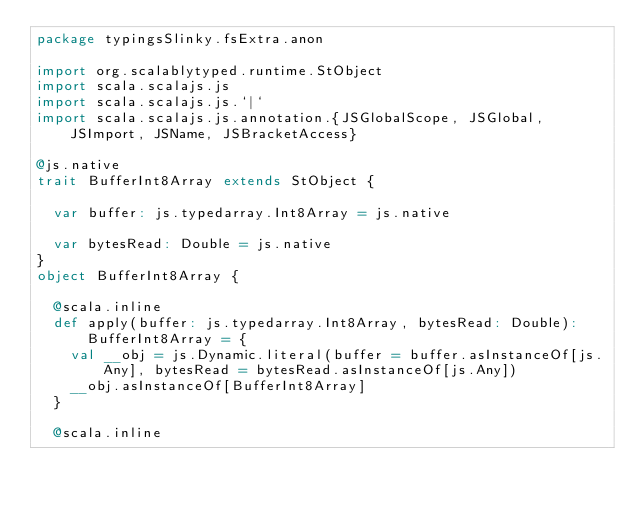<code> <loc_0><loc_0><loc_500><loc_500><_Scala_>package typingsSlinky.fsExtra.anon

import org.scalablytyped.runtime.StObject
import scala.scalajs.js
import scala.scalajs.js.`|`
import scala.scalajs.js.annotation.{JSGlobalScope, JSGlobal, JSImport, JSName, JSBracketAccess}

@js.native
trait BufferInt8Array extends StObject {
  
  var buffer: js.typedarray.Int8Array = js.native
  
  var bytesRead: Double = js.native
}
object BufferInt8Array {
  
  @scala.inline
  def apply(buffer: js.typedarray.Int8Array, bytesRead: Double): BufferInt8Array = {
    val __obj = js.Dynamic.literal(buffer = buffer.asInstanceOf[js.Any], bytesRead = bytesRead.asInstanceOf[js.Any])
    __obj.asInstanceOf[BufferInt8Array]
  }
  
  @scala.inline</code> 